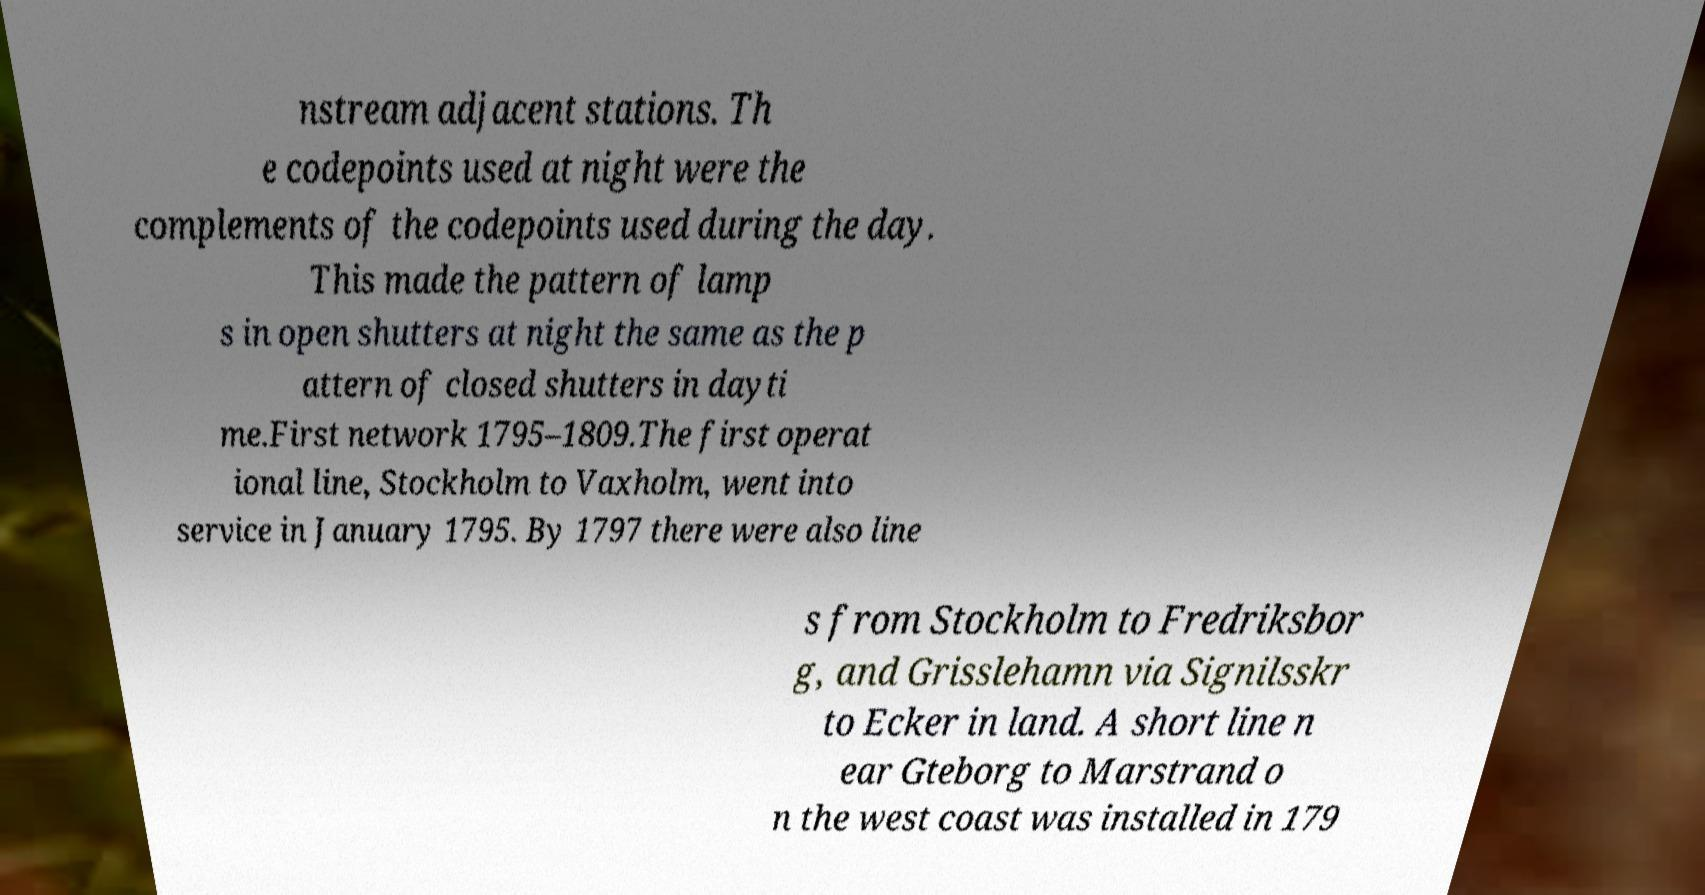There's text embedded in this image that I need extracted. Can you transcribe it verbatim? nstream adjacent stations. Th e codepoints used at night were the complements of the codepoints used during the day. This made the pattern of lamp s in open shutters at night the same as the p attern of closed shutters in dayti me.First network 1795–1809.The first operat ional line, Stockholm to Vaxholm, went into service in January 1795. By 1797 there were also line s from Stockholm to Fredriksbor g, and Grisslehamn via Signilsskr to Ecker in land. A short line n ear Gteborg to Marstrand o n the west coast was installed in 179 